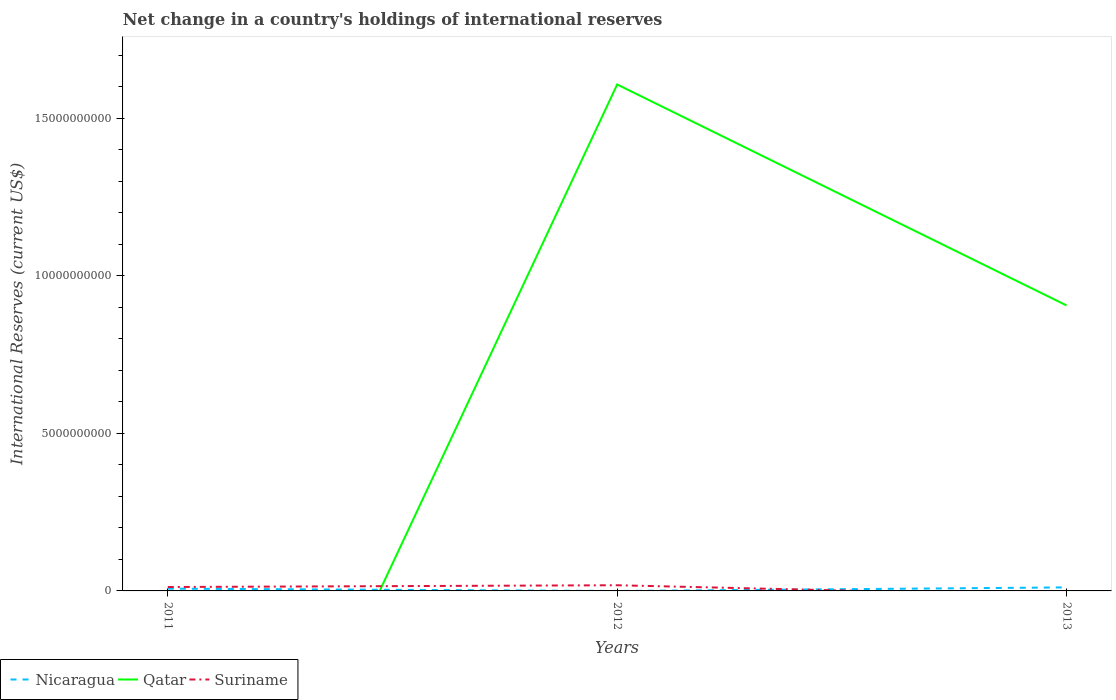Does the line corresponding to Qatar intersect with the line corresponding to Nicaragua?
Offer a terse response. Yes. What is the total international reserves in Suriname in the graph?
Make the answer very short. -5.60e+07. What is the difference between the highest and the second highest international reserves in Qatar?
Provide a short and direct response. 1.61e+1. What is the difference between the highest and the lowest international reserves in Qatar?
Offer a terse response. 2. Is the international reserves in Suriname strictly greater than the international reserves in Nicaragua over the years?
Offer a terse response. No. Are the values on the major ticks of Y-axis written in scientific E-notation?
Make the answer very short. No. Does the graph contain any zero values?
Provide a succinct answer. Yes. Where does the legend appear in the graph?
Your answer should be compact. Bottom left. How many legend labels are there?
Your answer should be compact. 3. What is the title of the graph?
Your answer should be very brief. Net change in a country's holdings of international reserves. What is the label or title of the Y-axis?
Your answer should be very brief. International Reserves (current US$). What is the International Reserves (current US$) of Nicaragua in 2011?
Provide a succinct answer. 7.26e+07. What is the International Reserves (current US$) of Suriname in 2011?
Your answer should be compact. 1.24e+08. What is the International Reserves (current US$) in Nicaragua in 2012?
Make the answer very short. 0. What is the International Reserves (current US$) of Qatar in 2012?
Keep it short and to the point. 1.61e+1. What is the International Reserves (current US$) in Suriname in 2012?
Provide a short and direct response. 1.80e+08. What is the International Reserves (current US$) of Nicaragua in 2013?
Offer a terse response. 1.12e+08. What is the International Reserves (current US$) of Qatar in 2013?
Ensure brevity in your answer.  9.06e+09. Across all years, what is the maximum International Reserves (current US$) of Nicaragua?
Your response must be concise. 1.12e+08. Across all years, what is the maximum International Reserves (current US$) in Qatar?
Your answer should be very brief. 1.61e+1. Across all years, what is the maximum International Reserves (current US$) in Suriname?
Keep it short and to the point. 1.80e+08. Across all years, what is the minimum International Reserves (current US$) of Suriname?
Ensure brevity in your answer.  0. What is the total International Reserves (current US$) in Nicaragua in the graph?
Offer a terse response. 1.84e+08. What is the total International Reserves (current US$) of Qatar in the graph?
Keep it short and to the point. 2.51e+1. What is the total International Reserves (current US$) of Suriname in the graph?
Keep it short and to the point. 3.04e+08. What is the difference between the International Reserves (current US$) of Suriname in 2011 and that in 2012?
Your answer should be compact. -5.60e+07. What is the difference between the International Reserves (current US$) in Nicaragua in 2011 and that in 2013?
Make the answer very short. -3.91e+07. What is the difference between the International Reserves (current US$) of Qatar in 2012 and that in 2013?
Provide a succinct answer. 7.02e+09. What is the difference between the International Reserves (current US$) of Nicaragua in 2011 and the International Reserves (current US$) of Qatar in 2012?
Offer a very short reply. -1.60e+1. What is the difference between the International Reserves (current US$) of Nicaragua in 2011 and the International Reserves (current US$) of Suriname in 2012?
Your response must be concise. -1.08e+08. What is the difference between the International Reserves (current US$) of Nicaragua in 2011 and the International Reserves (current US$) of Qatar in 2013?
Provide a succinct answer. -8.99e+09. What is the average International Reserves (current US$) in Nicaragua per year?
Give a very brief answer. 6.14e+07. What is the average International Reserves (current US$) of Qatar per year?
Offer a terse response. 8.38e+09. What is the average International Reserves (current US$) in Suriname per year?
Offer a terse response. 1.01e+08. In the year 2011, what is the difference between the International Reserves (current US$) of Nicaragua and International Reserves (current US$) of Suriname?
Offer a very short reply. -5.15e+07. In the year 2012, what is the difference between the International Reserves (current US$) of Qatar and International Reserves (current US$) of Suriname?
Offer a terse response. 1.59e+1. In the year 2013, what is the difference between the International Reserves (current US$) of Nicaragua and International Reserves (current US$) of Qatar?
Keep it short and to the point. -8.95e+09. What is the ratio of the International Reserves (current US$) of Suriname in 2011 to that in 2012?
Keep it short and to the point. 0.69. What is the ratio of the International Reserves (current US$) of Nicaragua in 2011 to that in 2013?
Keep it short and to the point. 0.65. What is the ratio of the International Reserves (current US$) in Qatar in 2012 to that in 2013?
Offer a very short reply. 1.77. What is the difference between the highest and the lowest International Reserves (current US$) in Nicaragua?
Make the answer very short. 1.12e+08. What is the difference between the highest and the lowest International Reserves (current US$) of Qatar?
Keep it short and to the point. 1.61e+1. What is the difference between the highest and the lowest International Reserves (current US$) in Suriname?
Provide a short and direct response. 1.80e+08. 